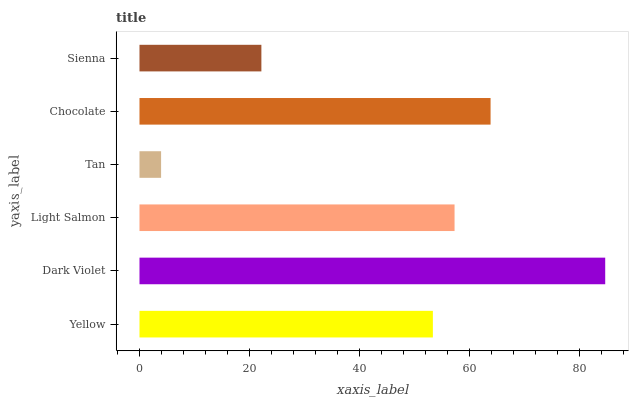Is Tan the minimum?
Answer yes or no. Yes. Is Dark Violet the maximum?
Answer yes or no. Yes. Is Light Salmon the minimum?
Answer yes or no. No. Is Light Salmon the maximum?
Answer yes or no. No. Is Dark Violet greater than Light Salmon?
Answer yes or no. Yes. Is Light Salmon less than Dark Violet?
Answer yes or no. Yes. Is Light Salmon greater than Dark Violet?
Answer yes or no. No. Is Dark Violet less than Light Salmon?
Answer yes or no. No. Is Light Salmon the high median?
Answer yes or no. Yes. Is Yellow the low median?
Answer yes or no. Yes. Is Sienna the high median?
Answer yes or no. No. Is Sienna the low median?
Answer yes or no. No. 